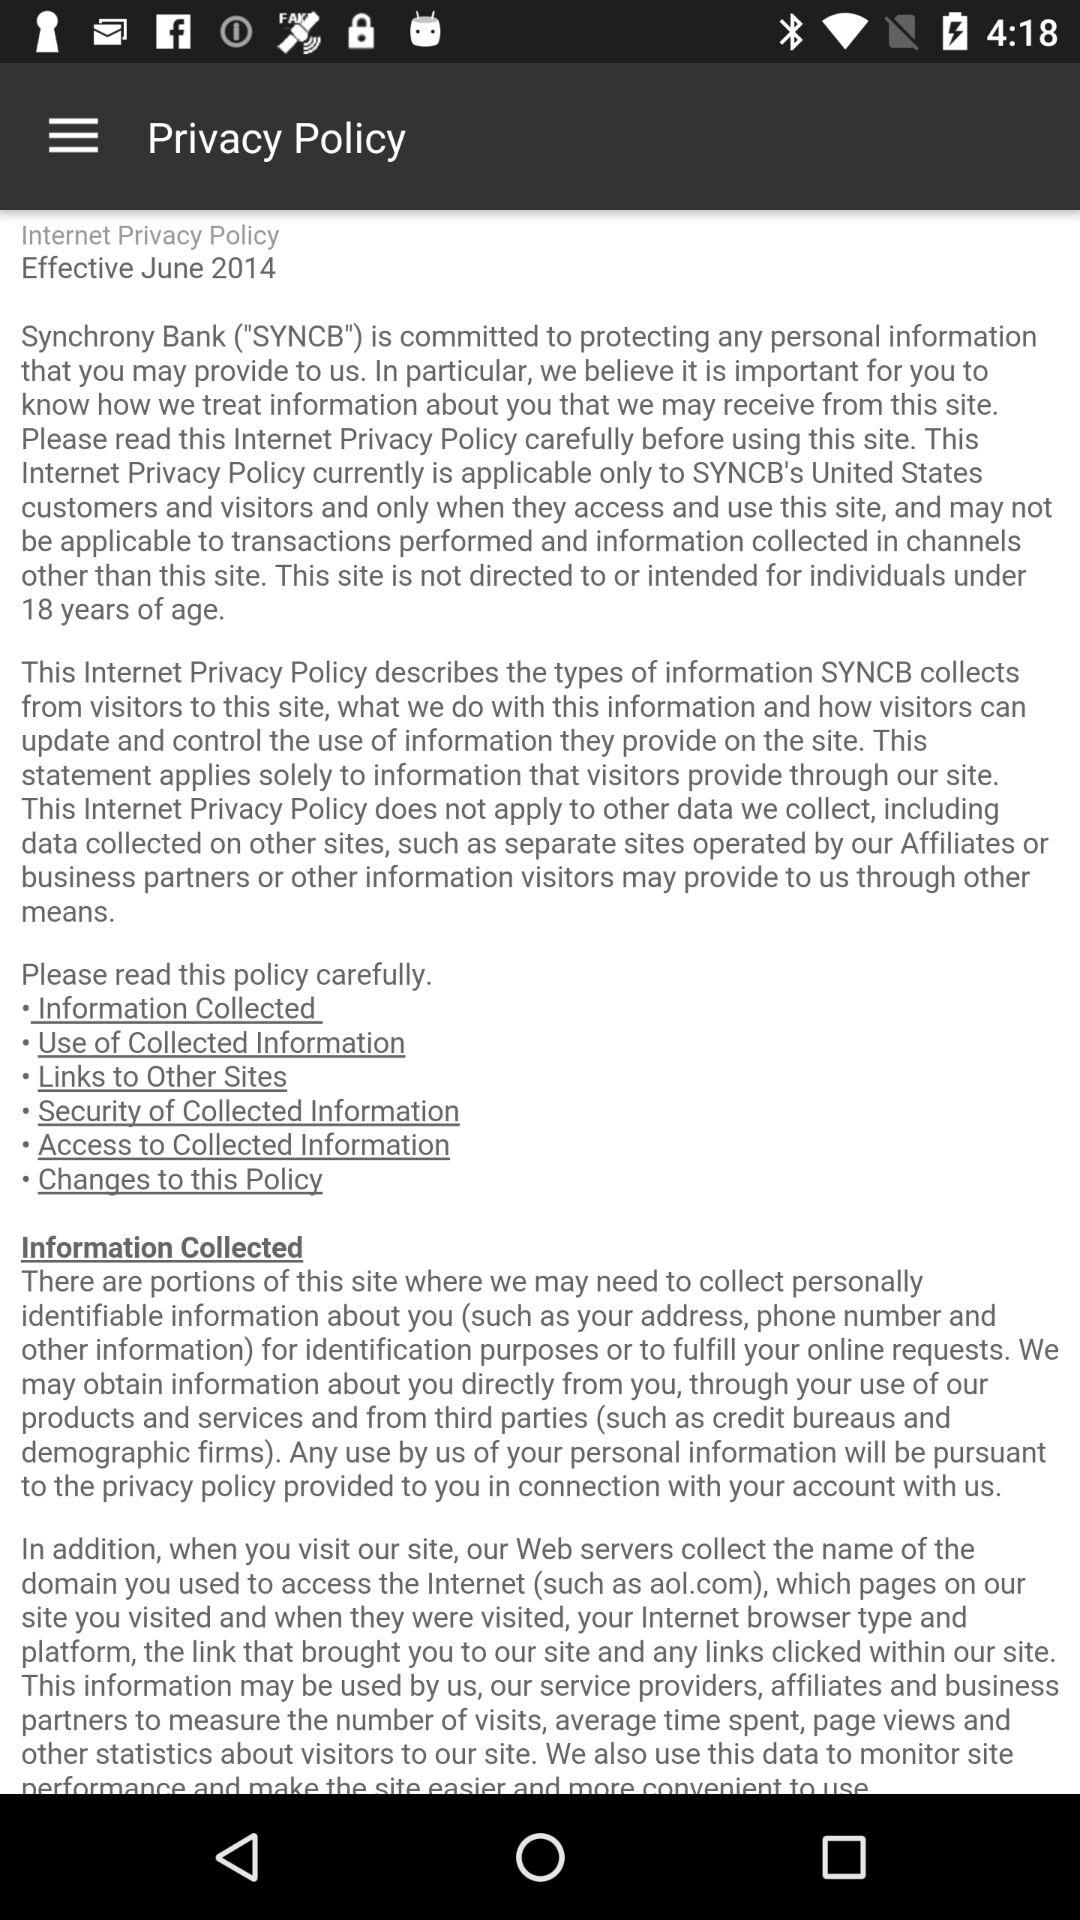What year did the privacy policy become effective? The privacy policy became effective in 2014. 